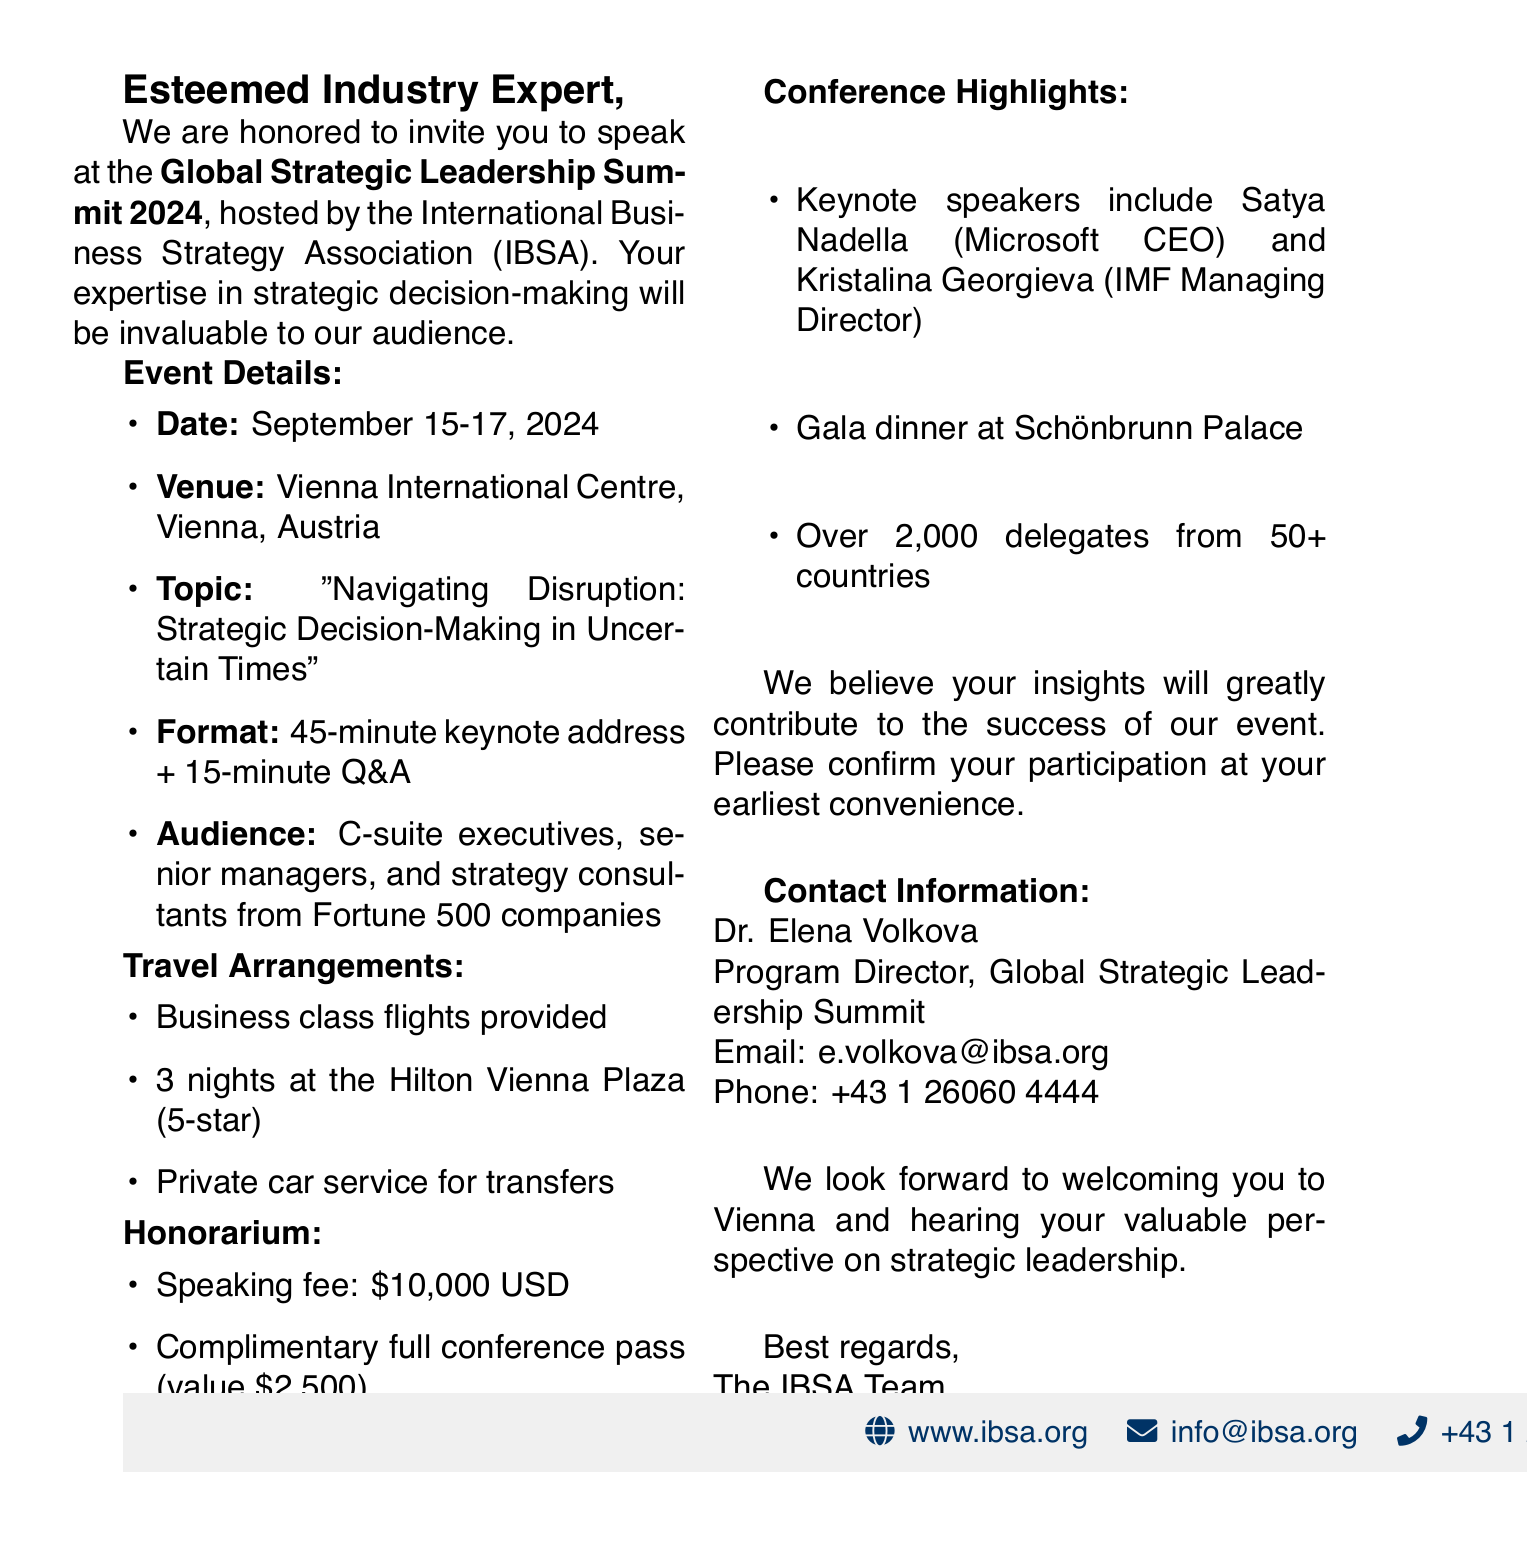What is the name of the conference? The document states the name of the conference as "Global Strategic Leadership Summit 2024."
Answer: Global Strategic Leadership Summit 2024 Who is hosting the conference? The host organization mentioned in the document is the International Business Strategy Association (IBSA).
Answer: International Business Strategy Association (IBSA) What is the date of the event? The document specifies the date of the event as September 15-17, 2024.
Answer: September 15-17, 2024 What is the speaking fee offered? According to the document, the speaking fee is $10,000 USD.
Answer: $10,000 USD How long is the keynote address? The document mentions a duration of 45 minutes for the keynote address.
Answer: 45 minutes What type of transportation is provided for local transfers? The document states that there is a private car service provided for local transportation.
Answer: Private car service What is one of the highlights of the conference? The document notes that a highlight of the conference is a gala dinner at Schönbrunn Palace.
Answer: Gala dinner at Schönbrunn Palace How many delegates are expected to attend? The expected number of delegates mentioned in the document is over 2,000.
Answer: Over 2,000 Who should be contacted for more information? The document provides the contact person's name as Dr. Elena Volkova for more information.
Answer: Dr. Elena Volkova 